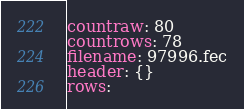<code> <loc_0><loc_0><loc_500><loc_500><_YAML_>countraw: 80
countrows: 78
filename: 97996.fec
header: {}
rows:</code> 